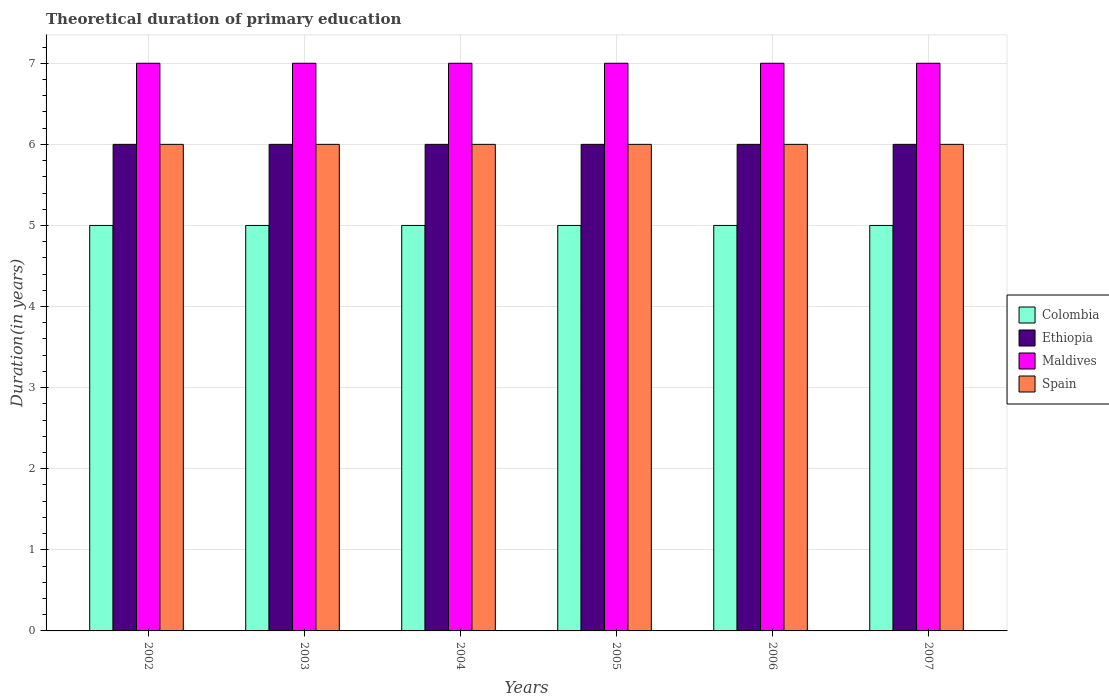How many bars are there on the 1st tick from the left?
Give a very brief answer. 4. How many bars are there on the 2nd tick from the right?
Provide a succinct answer. 4. What is the label of the 5th group of bars from the left?
Give a very brief answer. 2006. What is the total theoretical duration of primary education in Colombia in 2004?
Your answer should be very brief. 5. Across all years, what is the minimum total theoretical duration of primary education in Maldives?
Provide a short and direct response. 7. In which year was the total theoretical duration of primary education in Maldives minimum?
Offer a very short reply. 2002. What is the total total theoretical duration of primary education in Spain in the graph?
Your response must be concise. 36. What is the difference between the total theoretical duration of primary education in Maldives in 2007 and the total theoretical duration of primary education in Colombia in 2003?
Ensure brevity in your answer.  2. What is the average total theoretical duration of primary education in Maldives per year?
Your response must be concise. 7. In the year 2005, what is the difference between the total theoretical duration of primary education in Colombia and total theoretical duration of primary education in Ethiopia?
Ensure brevity in your answer.  -1. In how many years, is the total theoretical duration of primary education in Colombia greater than 2.4 years?
Offer a very short reply. 6. What is the ratio of the total theoretical duration of primary education in Ethiopia in 2003 to that in 2007?
Your answer should be compact. 1. Is the difference between the total theoretical duration of primary education in Colombia in 2003 and 2005 greater than the difference between the total theoretical duration of primary education in Ethiopia in 2003 and 2005?
Provide a short and direct response. No. What is the difference between the highest and the second highest total theoretical duration of primary education in Colombia?
Offer a very short reply. 0. In how many years, is the total theoretical duration of primary education in Maldives greater than the average total theoretical duration of primary education in Maldives taken over all years?
Your response must be concise. 0. Is the sum of the total theoretical duration of primary education in Ethiopia in 2004 and 2006 greater than the maximum total theoretical duration of primary education in Colombia across all years?
Provide a short and direct response. Yes. Is it the case that in every year, the sum of the total theoretical duration of primary education in Colombia and total theoretical duration of primary education in Spain is greater than the sum of total theoretical duration of primary education in Ethiopia and total theoretical duration of primary education in Maldives?
Give a very brief answer. No. What does the 2nd bar from the left in 2002 represents?
Keep it short and to the point. Ethiopia. What does the 4th bar from the right in 2004 represents?
Provide a short and direct response. Colombia. Is it the case that in every year, the sum of the total theoretical duration of primary education in Ethiopia and total theoretical duration of primary education in Maldives is greater than the total theoretical duration of primary education in Colombia?
Provide a succinct answer. Yes. How many bars are there?
Provide a succinct answer. 24. Are all the bars in the graph horizontal?
Keep it short and to the point. No. How many years are there in the graph?
Provide a succinct answer. 6. What is the difference between two consecutive major ticks on the Y-axis?
Offer a very short reply. 1. Are the values on the major ticks of Y-axis written in scientific E-notation?
Offer a terse response. No. How are the legend labels stacked?
Offer a terse response. Vertical. What is the title of the graph?
Your answer should be compact. Theoretical duration of primary education. Does "El Salvador" appear as one of the legend labels in the graph?
Offer a terse response. No. What is the label or title of the Y-axis?
Give a very brief answer. Duration(in years). What is the Duration(in years) of Ethiopia in 2002?
Give a very brief answer. 6. What is the Duration(in years) of Ethiopia in 2003?
Provide a succinct answer. 6. What is the Duration(in years) of Maldives in 2003?
Make the answer very short. 7. What is the Duration(in years) in Colombia in 2004?
Provide a succinct answer. 5. What is the Duration(in years) of Ethiopia in 2004?
Provide a succinct answer. 6. What is the Duration(in years) in Maldives in 2005?
Offer a terse response. 7. What is the Duration(in years) of Maldives in 2006?
Your response must be concise. 7. What is the Duration(in years) in Colombia in 2007?
Make the answer very short. 5. What is the Duration(in years) in Ethiopia in 2007?
Your response must be concise. 6. Across all years, what is the maximum Duration(in years) of Colombia?
Your answer should be compact. 5. Across all years, what is the maximum Duration(in years) of Ethiopia?
Keep it short and to the point. 6. Across all years, what is the maximum Duration(in years) in Spain?
Your response must be concise. 6. What is the total Duration(in years) of Colombia in the graph?
Provide a short and direct response. 30. What is the total Duration(in years) in Maldives in the graph?
Make the answer very short. 42. What is the total Duration(in years) of Spain in the graph?
Your answer should be very brief. 36. What is the difference between the Duration(in years) in Ethiopia in 2002 and that in 2003?
Provide a succinct answer. 0. What is the difference between the Duration(in years) in Maldives in 2002 and that in 2003?
Your answer should be very brief. 0. What is the difference between the Duration(in years) in Spain in 2002 and that in 2003?
Ensure brevity in your answer.  0. What is the difference between the Duration(in years) in Colombia in 2002 and that in 2004?
Your response must be concise. 0. What is the difference between the Duration(in years) in Spain in 2002 and that in 2004?
Offer a terse response. 0. What is the difference between the Duration(in years) of Colombia in 2002 and that in 2005?
Provide a short and direct response. 0. What is the difference between the Duration(in years) of Ethiopia in 2002 and that in 2005?
Your answer should be compact. 0. What is the difference between the Duration(in years) of Maldives in 2002 and that in 2005?
Offer a terse response. 0. What is the difference between the Duration(in years) in Colombia in 2002 and that in 2006?
Make the answer very short. 0. What is the difference between the Duration(in years) of Maldives in 2002 and that in 2006?
Your answer should be very brief. 0. What is the difference between the Duration(in years) in Colombia in 2002 and that in 2007?
Give a very brief answer. 0. What is the difference between the Duration(in years) in Ethiopia in 2002 and that in 2007?
Provide a succinct answer. 0. What is the difference between the Duration(in years) in Spain in 2002 and that in 2007?
Offer a terse response. 0. What is the difference between the Duration(in years) in Ethiopia in 2003 and that in 2004?
Make the answer very short. 0. What is the difference between the Duration(in years) in Maldives in 2003 and that in 2004?
Your answer should be compact. 0. What is the difference between the Duration(in years) of Spain in 2003 and that in 2004?
Provide a short and direct response. 0. What is the difference between the Duration(in years) in Colombia in 2003 and that in 2005?
Ensure brevity in your answer.  0. What is the difference between the Duration(in years) in Maldives in 2003 and that in 2005?
Keep it short and to the point. 0. What is the difference between the Duration(in years) of Maldives in 2003 and that in 2006?
Give a very brief answer. 0. What is the difference between the Duration(in years) of Spain in 2003 and that in 2006?
Ensure brevity in your answer.  0. What is the difference between the Duration(in years) of Maldives in 2003 and that in 2007?
Keep it short and to the point. 0. What is the difference between the Duration(in years) in Ethiopia in 2004 and that in 2005?
Make the answer very short. 0. What is the difference between the Duration(in years) in Maldives in 2004 and that in 2005?
Offer a very short reply. 0. What is the difference between the Duration(in years) in Spain in 2004 and that in 2005?
Your answer should be very brief. 0. What is the difference between the Duration(in years) of Colombia in 2004 and that in 2006?
Your answer should be very brief. 0. What is the difference between the Duration(in years) of Ethiopia in 2004 and that in 2006?
Provide a succinct answer. 0. What is the difference between the Duration(in years) in Maldives in 2004 and that in 2006?
Give a very brief answer. 0. What is the difference between the Duration(in years) of Spain in 2004 and that in 2006?
Offer a terse response. 0. What is the difference between the Duration(in years) of Colombia in 2004 and that in 2007?
Provide a short and direct response. 0. What is the difference between the Duration(in years) in Maldives in 2004 and that in 2007?
Your answer should be compact. 0. What is the difference between the Duration(in years) of Spain in 2004 and that in 2007?
Your answer should be compact. 0. What is the difference between the Duration(in years) of Colombia in 2005 and that in 2006?
Offer a very short reply. 0. What is the difference between the Duration(in years) of Maldives in 2005 and that in 2006?
Ensure brevity in your answer.  0. What is the difference between the Duration(in years) in Spain in 2005 and that in 2006?
Your answer should be compact. 0. What is the difference between the Duration(in years) of Ethiopia in 2006 and that in 2007?
Ensure brevity in your answer.  0. What is the difference between the Duration(in years) of Colombia in 2002 and the Duration(in years) of Maldives in 2003?
Provide a short and direct response. -2. What is the difference between the Duration(in years) of Colombia in 2002 and the Duration(in years) of Spain in 2004?
Keep it short and to the point. -1. What is the difference between the Duration(in years) of Ethiopia in 2002 and the Duration(in years) of Maldives in 2004?
Provide a short and direct response. -1. What is the difference between the Duration(in years) in Ethiopia in 2002 and the Duration(in years) in Spain in 2004?
Provide a succinct answer. 0. What is the difference between the Duration(in years) of Colombia in 2002 and the Duration(in years) of Ethiopia in 2005?
Offer a terse response. -1. What is the difference between the Duration(in years) in Colombia in 2002 and the Duration(in years) in Spain in 2005?
Ensure brevity in your answer.  -1. What is the difference between the Duration(in years) in Colombia in 2002 and the Duration(in years) in Ethiopia in 2006?
Ensure brevity in your answer.  -1. What is the difference between the Duration(in years) in Colombia in 2002 and the Duration(in years) in Maldives in 2006?
Your answer should be very brief. -2. What is the difference between the Duration(in years) in Colombia in 2002 and the Duration(in years) in Spain in 2006?
Offer a terse response. -1. What is the difference between the Duration(in years) in Maldives in 2002 and the Duration(in years) in Spain in 2006?
Ensure brevity in your answer.  1. What is the difference between the Duration(in years) in Colombia in 2002 and the Duration(in years) in Ethiopia in 2007?
Ensure brevity in your answer.  -1. What is the difference between the Duration(in years) in Colombia in 2002 and the Duration(in years) in Maldives in 2007?
Your answer should be very brief. -2. What is the difference between the Duration(in years) in Colombia in 2002 and the Duration(in years) in Spain in 2007?
Provide a succinct answer. -1. What is the difference between the Duration(in years) in Ethiopia in 2002 and the Duration(in years) in Maldives in 2007?
Your answer should be very brief. -1. What is the difference between the Duration(in years) of Maldives in 2002 and the Duration(in years) of Spain in 2007?
Offer a terse response. 1. What is the difference between the Duration(in years) of Colombia in 2003 and the Duration(in years) of Ethiopia in 2004?
Provide a short and direct response. -1. What is the difference between the Duration(in years) of Ethiopia in 2003 and the Duration(in years) of Maldives in 2004?
Your answer should be compact. -1. What is the difference between the Duration(in years) in Colombia in 2003 and the Duration(in years) in Ethiopia in 2005?
Provide a succinct answer. -1. What is the difference between the Duration(in years) of Colombia in 2003 and the Duration(in years) of Maldives in 2005?
Your answer should be very brief. -2. What is the difference between the Duration(in years) in Colombia in 2003 and the Duration(in years) in Ethiopia in 2006?
Provide a succinct answer. -1. What is the difference between the Duration(in years) in Ethiopia in 2003 and the Duration(in years) in Maldives in 2006?
Give a very brief answer. -1. What is the difference between the Duration(in years) in Ethiopia in 2003 and the Duration(in years) in Spain in 2006?
Offer a terse response. 0. What is the difference between the Duration(in years) in Maldives in 2003 and the Duration(in years) in Spain in 2006?
Your answer should be compact. 1. What is the difference between the Duration(in years) of Colombia in 2003 and the Duration(in years) of Maldives in 2007?
Make the answer very short. -2. What is the difference between the Duration(in years) of Maldives in 2003 and the Duration(in years) of Spain in 2007?
Provide a succinct answer. 1. What is the difference between the Duration(in years) in Colombia in 2004 and the Duration(in years) in Ethiopia in 2005?
Provide a succinct answer. -1. What is the difference between the Duration(in years) of Ethiopia in 2004 and the Duration(in years) of Maldives in 2005?
Your response must be concise. -1. What is the difference between the Duration(in years) in Ethiopia in 2004 and the Duration(in years) in Spain in 2005?
Keep it short and to the point. 0. What is the difference between the Duration(in years) in Maldives in 2004 and the Duration(in years) in Spain in 2005?
Offer a terse response. 1. What is the difference between the Duration(in years) of Colombia in 2004 and the Duration(in years) of Ethiopia in 2006?
Offer a very short reply. -1. What is the difference between the Duration(in years) of Colombia in 2004 and the Duration(in years) of Maldives in 2006?
Ensure brevity in your answer.  -2. What is the difference between the Duration(in years) of Ethiopia in 2004 and the Duration(in years) of Maldives in 2006?
Ensure brevity in your answer.  -1. What is the difference between the Duration(in years) of Ethiopia in 2004 and the Duration(in years) of Spain in 2006?
Provide a succinct answer. 0. What is the difference between the Duration(in years) in Maldives in 2004 and the Duration(in years) in Spain in 2006?
Make the answer very short. 1. What is the difference between the Duration(in years) of Colombia in 2004 and the Duration(in years) of Maldives in 2007?
Ensure brevity in your answer.  -2. What is the difference between the Duration(in years) in Colombia in 2004 and the Duration(in years) in Spain in 2007?
Provide a short and direct response. -1. What is the difference between the Duration(in years) in Ethiopia in 2004 and the Duration(in years) in Maldives in 2007?
Provide a succinct answer. -1. What is the difference between the Duration(in years) of Ethiopia in 2004 and the Duration(in years) of Spain in 2007?
Offer a very short reply. 0. What is the difference between the Duration(in years) in Colombia in 2005 and the Duration(in years) in Ethiopia in 2006?
Make the answer very short. -1. What is the difference between the Duration(in years) in Ethiopia in 2005 and the Duration(in years) in Spain in 2006?
Ensure brevity in your answer.  0. What is the difference between the Duration(in years) of Colombia in 2005 and the Duration(in years) of Ethiopia in 2007?
Your response must be concise. -1. What is the difference between the Duration(in years) of Colombia in 2005 and the Duration(in years) of Maldives in 2007?
Offer a very short reply. -2. What is the difference between the Duration(in years) in Colombia in 2005 and the Duration(in years) in Spain in 2007?
Your answer should be very brief. -1. What is the difference between the Duration(in years) of Ethiopia in 2005 and the Duration(in years) of Spain in 2007?
Make the answer very short. 0. What is the difference between the Duration(in years) of Maldives in 2005 and the Duration(in years) of Spain in 2007?
Your answer should be compact. 1. What is the difference between the Duration(in years) of Colombia in 2006 and the Duration(in years) of Spain in 2007?
Offer a very short reply. -1. What is the difference between the Duration(in years) in Ethiopia in 2006 and the Duration(in years) in Maldives in 2007?
Make the answer very short. -1. What is the difference between the Duration(in years) of Maldives in 2006 and the Duration(in years) of Spain in 2007?
Your answer should be very brief. 1. What is the average Duration(in years) in Maldives per year?
Make the answer very short. 7. In the year 2002, what is the difference between the Duration(in years) of Ethiopia and Duration(in years) of Maldives?
Give a very brief answer. -1. In the year 2003, what is the difference between the Duration(in years) in Colombia and Duration(in years) in Ethiopia?
Your answer should be very brief. -1. In the year 2003, what is the difference between the Duration(in years) of Colombia and Duration(in years) of Maldives?
Ensure brevity in your answer.  -2. In the year 2003, what is the difference between the Duration(in years) of Colombia and Duration(in years) of Spain?
Provide a succinct answer. -1. In the year 2003, what is the difference between the Duration(in years) in Ethiopia and Duration(in years) in Spain?
Offer a very short reply. 0. In the year 2003, what is the difference between the Duration(in years) of Maldives and Duration(in years) of Spain?
Provide a succinct answer. 1. In the year 2004, what is the difference between the Duration(in years) of Colombia and Duration(in years) of Maldives?
Your response must be concise. -2. In the year 2004, what is the difference between the Duration(in years) of Colombia and Duration(in years) of Spain?
Offer a terse response. -1. In the year 2004, what is the difference between the Duration(in years) in Ethiopia and Duration(in years) in Maldives?
Your answer should be very brief. -1. In the year 2004, what is the difference between the Duration(in years) in Ethiopia and Duration(in years) in Spain?
Your answer should be very brief. 0. In the year 2005, what is the difference between the Duration(in years) of Colombia and Duration(in years) of Ethiopia?
Offer a very short reply. -1. In the year 2005, what is the difference between the Duration(in years) of Colombia and Duration(in years) of Maldives?
Ensure brevity in your answer.  -2. In the year 2005, what is the difference between the Duration(in years) in Ethiopia and Duration(in years) in Spain?
Provide a succinct answer. 0. In the year 2006, what is the difference between the Duration(in years) in Colombia and Duration(in years) in Ethiopia?
Give a very brief answer. -1. In the year 2006, what is the difference between the Duration(in years) in Colombia and Duration(in years) in Spain?
Offer a terse response. -1. In the year 2006, what is the difference between the Duration(in years) of Ethiopia and Duration(in years) of Spain?
Ensure brevity in your answer.  0. In the year 2007, what is the difference between the Duration(in years) of Colombia and Duration(in years) of Maldives?
Give a very brief answer. -2. In the year 2007, what is the difference between the Duration(in years) of Colombia and Duration(in years) of Spain?
Provide a succinct answer. -1. In the year 2007, what is the difference between the Duration(in years) in Maldives and Duration(in years) in Spain?
Provide a succinct answer. 1. What is the ratio of the Duration(in years) in Colombia in 2002 to that in 2003?
Offer a very short reply. 1. What is the ratio of the Duration(in years) in Ethiopia in 2002 to that in 2003?
Provide a succinct answer. 1. What is the ratio of the Duration(in years) of Maldives in 2002 to that in 2003?
Ensure brevity in your answer.  1. What is the ratio of the Duration(in years) of Spain in 2002 to that in 2003?
Make the answer very short. 1. What is the ratio of the Duration(in years) of Colombia in 2002 to that in 2004?
Your answer should be compact. 1. What is the ratio of the Duration(in years) in Ethiopia in 2002 to that in 2004?
Your answer should be compact. 1. What is the ratio of the Duration(in years) in Colombia in 2002 to that in 2006?
Provide a short and direct response. 1. What is the ratio of the Duration(in years) of Ethiopia in 2002 to that in 2006?
Your response must be concise. 1. What is the ratio of the Duration(in years) in Spain in 2002 to that in 2006?
Ensure brevity in your answer.  1. What is the ratio of the Duration(in years) of Colombia in 2002 to that in 2007?
Make the answer very short. 1. What is the ratio of the Duration(in years) of Maldives in 2002 to that in 2007?
Your answer should be very brief. 1. What is the ratio of the Duration(in years) in Spain in 2002 to that in 2007?
Give a very brief answer. 1. What is the ratio of the Duration(in years) of Colombia in 2003 to that in 2004?
Provide a succinct answer. 1. What is the ratio of the Duration(in years) in Ethiopia in 2003 to that in 2004?
Provide a succinct answer. 1. What is the ratio of the Duration(in years) of Spain in 2003 to that in 2004?
Make the answer very short. 1. What is the ratio of the Duration(in years) in Ethiopia in 2003 to that in 2005?
Your answer should be very brief. 1. What is the ratio of the Duration(in years) in Spain in 2003 to that in 2005?
Make the answer very short. 1. What is the ratio of the Duration(in years) of Ethiopia in 2003 to that in 2006?
Provide a succinct answer. 1. What is the ratio of the Duration(in years) in Ethiopia in 2003 to that in 2007?
Make the answer very short. 1. What is the ratio of the Duration(in years) of Colombia in 2004 to that in 2005?
Make the answer very short. 1. What is the ratio of the Duration(in years) in Ethiopia in 2004 to that in 2005?
Provide a short and direct response. 1. What is the ratio of the Duration(in years) in Spain in 2004 to that in 2005?
Offer a very short reply. 1. What is the ratio of the Duration(in years) in Maldives in 2004 to that in 2006?
Provide a short and direct response. 1. What is the ratio of the Duration(in years) of Spain in 2004 to that in 2006?
Give a very brief answer. 1. What is the ratio of the Duration(in years) of Colombia in 2004 to that in 2007?
Provide a succinct answer. 1. What is the ratio of the Duration(in years) in Maldives in 2004 to that in 2007?
Your answer should be very brief. 1. What is the ratio of the Duration(in years) of Spain in 2004 to that in 2007?
Your answer should be very brief. 1. What is the ratio of the Duration(in years) in Ethiopia in 2005 to that in 2006?
Your response must be concise. 1. What is the ratio of the Duration(in years) in Maldives in 2005 to that in 2007?
Make the answer very short. 1. What is the ratio of the Duration(in years) in Colombia in 2006 to that in 2007?
Ensure brevity in your answer.  1. What is the ratio of the Duration(in years) in Ethiopia in 2006 to that in 2007?
Offer a terse response. 1. What is the difference between the highest and the second highest Duration(in years) in Ethiopia?
Ensure brevity in your answer.  0. What is the difference between the highest and the lowest Duration(in years) in Colombia?
Ensure brevity in your answer.  0. 